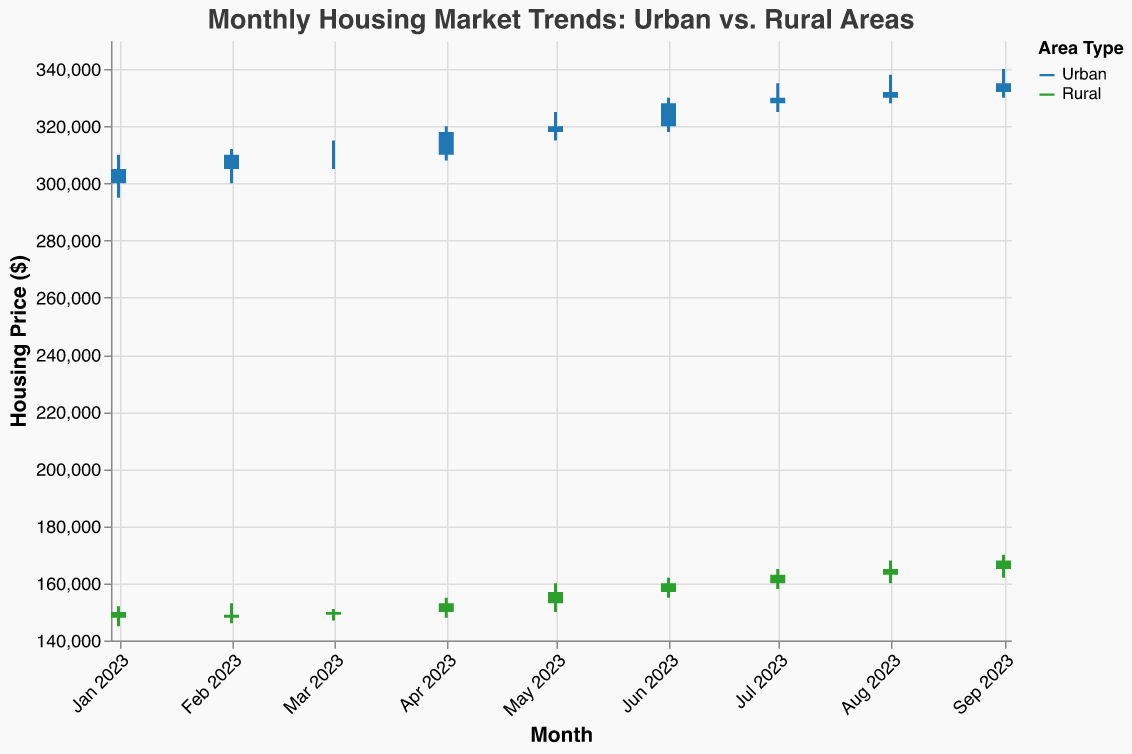What's the title of the plot? The title of the plot is displayed prominently at the top in a larger font size than the rest of the text elements on the chart. The title describes the overall theme or subject of the chart.
Answer: Monthly Housing Market Trends: Urban vs. Rural Areas What color represents Urban and what color represents Rural? The legend on the right side of the plot assigns colors to different categories. According to the legend, Urban data points are represented by blue, and Rural data points are represented by green.
Answer: Blue for Urban, Green for Rural Which area type had a higher closing price in September 2023? By observing the candlestick bars for September 2023, we compare the ending (closing) prices of Urban and Rural areas. The Urban area closed at 335,000, while the Rural area closed at 168,000.
Answer: Urban What was the high price for Rural areas in July 2023? By locating the candlestick for Rural in July 2023, we observe the top of the vertical line extending from the candlestick bar, which indicates the highest price. The high price for Rural areas in July 2023 is found to be 165,000.
Answer: 165,000 Calculate the average closing price for Urban areas from January to March 2023. Summing up the closing prices for Urban from January (305,000), February (310,000), and March (310,000), we get 925,000. The average is then calculated by dividing by the number of months (3), resulting in 308,333.33.
Answer: 308,333.33 How many months did both Urban and Rural areas see an increase in closing prices? We need to compare the closing price of each month to the previous month for both Urban and Rural areas. From the data, September (335,000 Urban; 168,000 Rural), August (332,000 Urban; 165,000 Rural), July (330,000 Urban; 163,000 Rural), June (328,000 Urban; 160,000 Rural), and April (318,000 Urban; 153,000 Rural) saw increases for both areas. In total, there are five months with increases in both areas.
Answer: Five months Which month had the smallest range (difference between high and low prices) for Urban areas? For each month, we calculate the difference between high and low prices for Urban areas: Jan (15,000), Feb (12,000), Mar (10,000), Apr (12,000), May (10,000), Jun (12,000), Jul (10,000), Aug (10,000), Sep (10,000). The smallest difference is 10,000, observed in March, May, July, August, and September.
Answer: March, May, July, August, September By how much did the closing price for Urban areas increase from January to September 2023? The closing price for Urban areas in January was 305,000, and in September, it was 335,000. The increase is calculated by subtracting the January closing price from the September closing price: 335,000 - 305,000 = 30,000.
Answer: 30,000 Compare the closing prices of Urban and Rural areas in March 2023. Which one is higher and by how much? In March 2023, Urban areas closed at 310,000, and Rural areas closed at 150,000. The difference is found by subtracting the March closing price for Rural areas from the March closing price for Urban areas: 310,000 - 150,000 = 160,000.
Answer: Urban by 160,000 